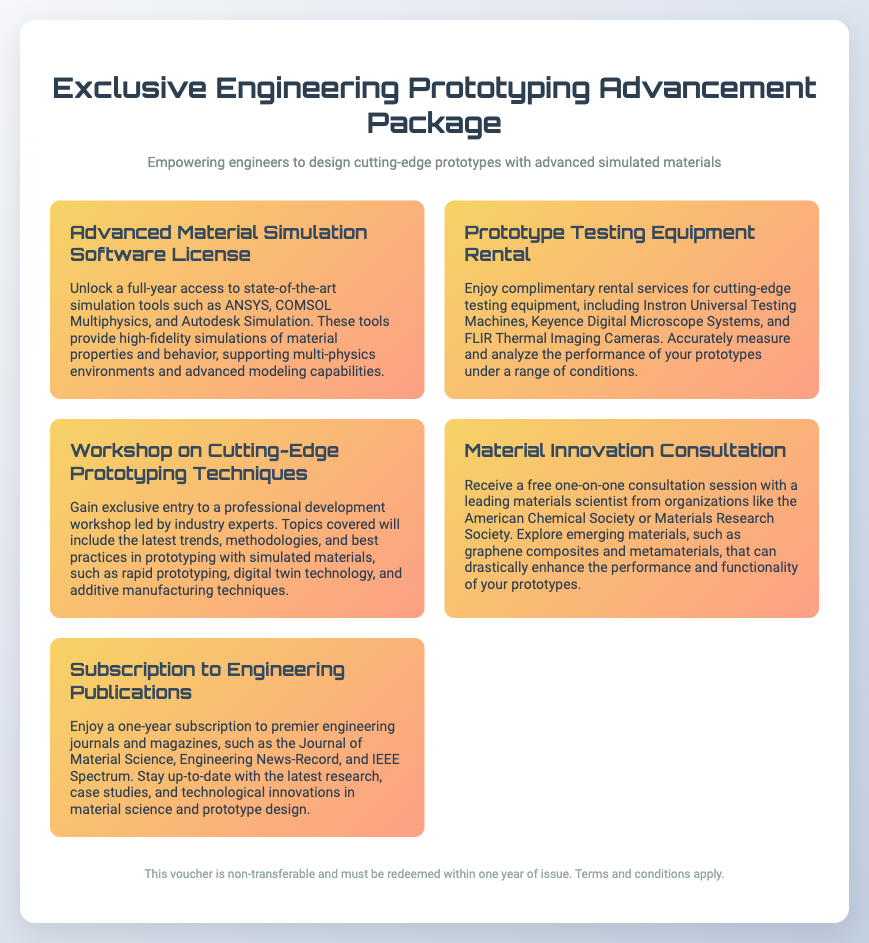What is the duration of the software license? The software license is for a full-year access.
Answer: full-year What types of testing equipment are included in the rental? The testing equipment includes Instron Universal Testing Machines, Keyence Digital Microscope Systems, and FLIR Thermal Imaging Cameras.
Answer: Instron Universal Testing Machines, Keyence Digital Microscope Systems, FLIR Thermal Imaging Cameras Who leads the workshop on prototyping techniques? The workshop is led by industry experts.
Answer: industry experts What is the focus of the material innovation consultation? The consultation focuses on exploring emerging materials that can enhance prototype performance.
Answer: exploring emerging materials What is provided with the subscription to engineering publications? The subscription includes premier engineering journals and magazines.
Answer: premier engineering journals and magazines Is the voucher transferable? The voucher is non-transferable.
Answer: non-transferable How are the topics in the workshop described? The topics covered include the latest trends, methodologies, and best practices in prototyping.
Answer: latest trends, methodologies, and best practices What type of simulations do the software tools support? The software tools support multi-physics environments.
Answer: multi-physics environments What is the main purpose of the advancement package? The purpose is to empower engineers to design cutting-edge prototypes.
Answer: empower engineers to design cutting-edge prototypes 